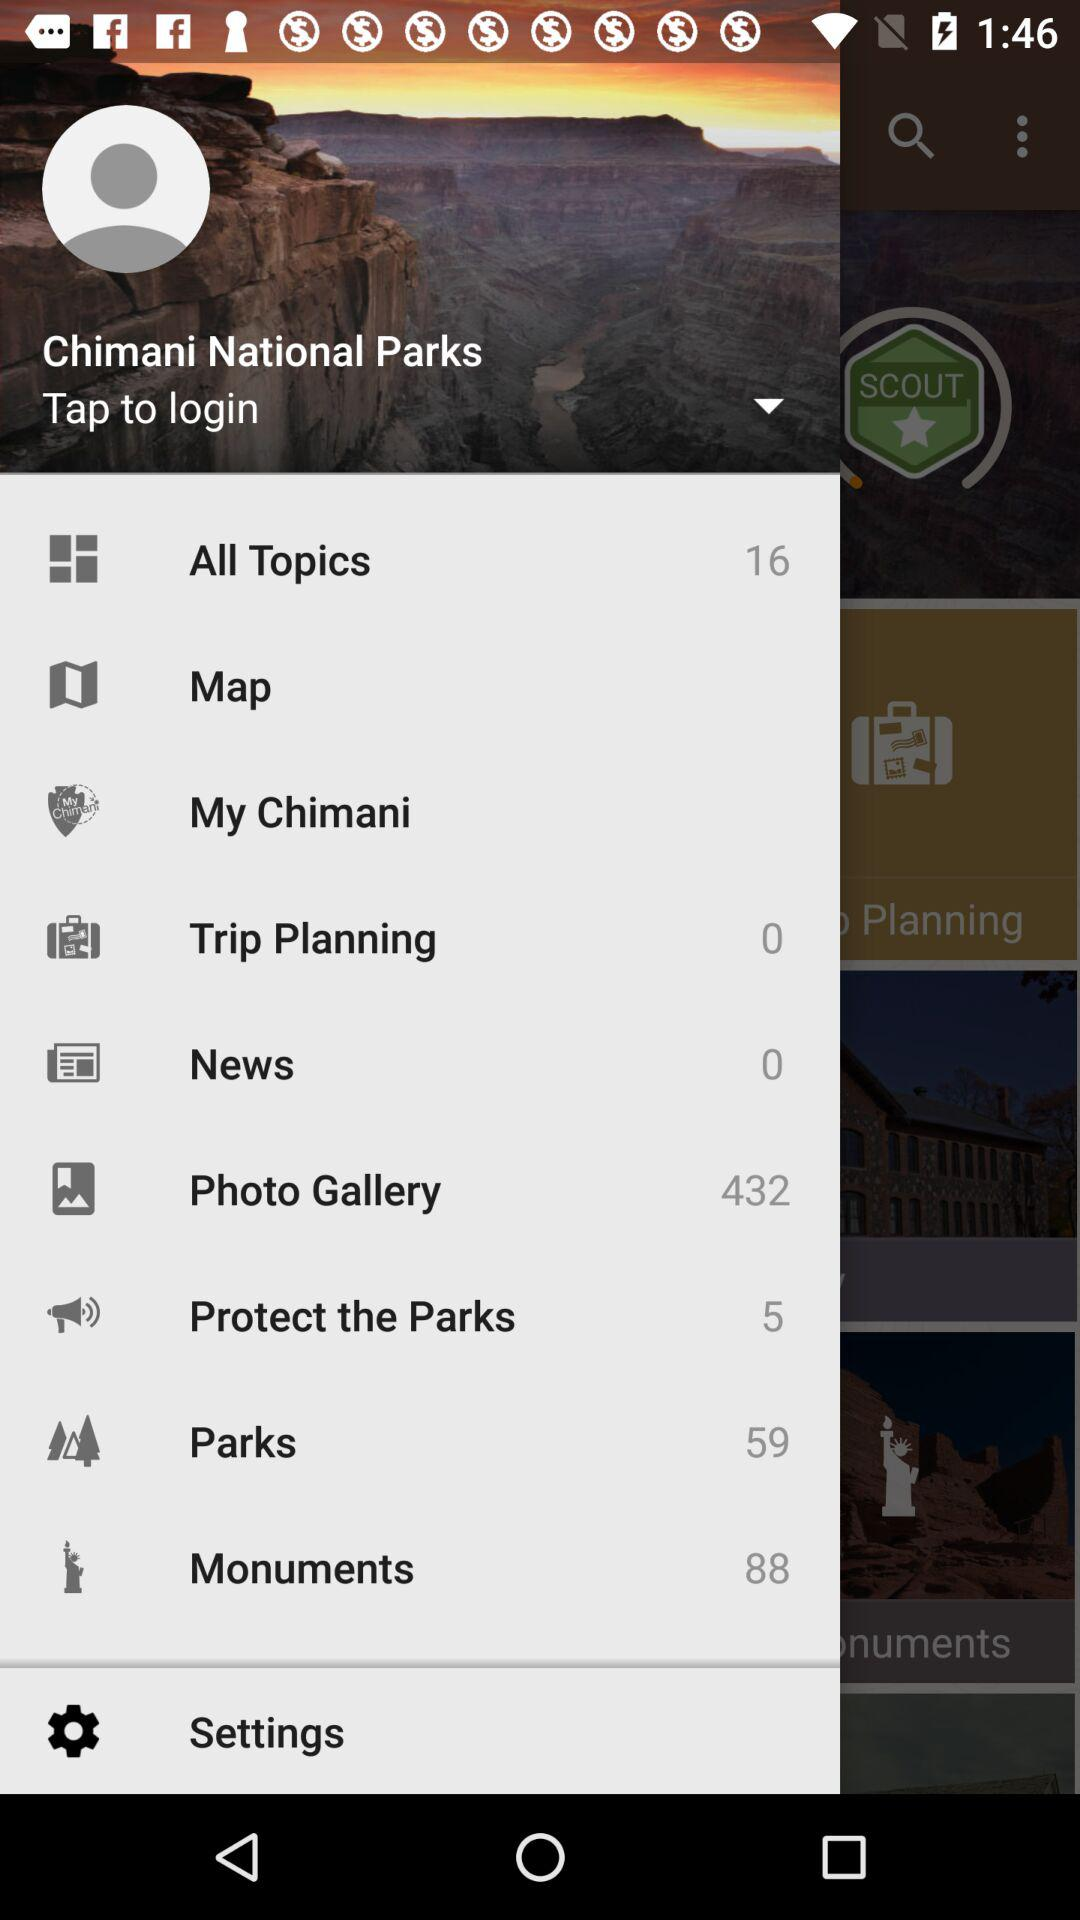What is the name of the application? The name of the application is "Chimani National Parks". 